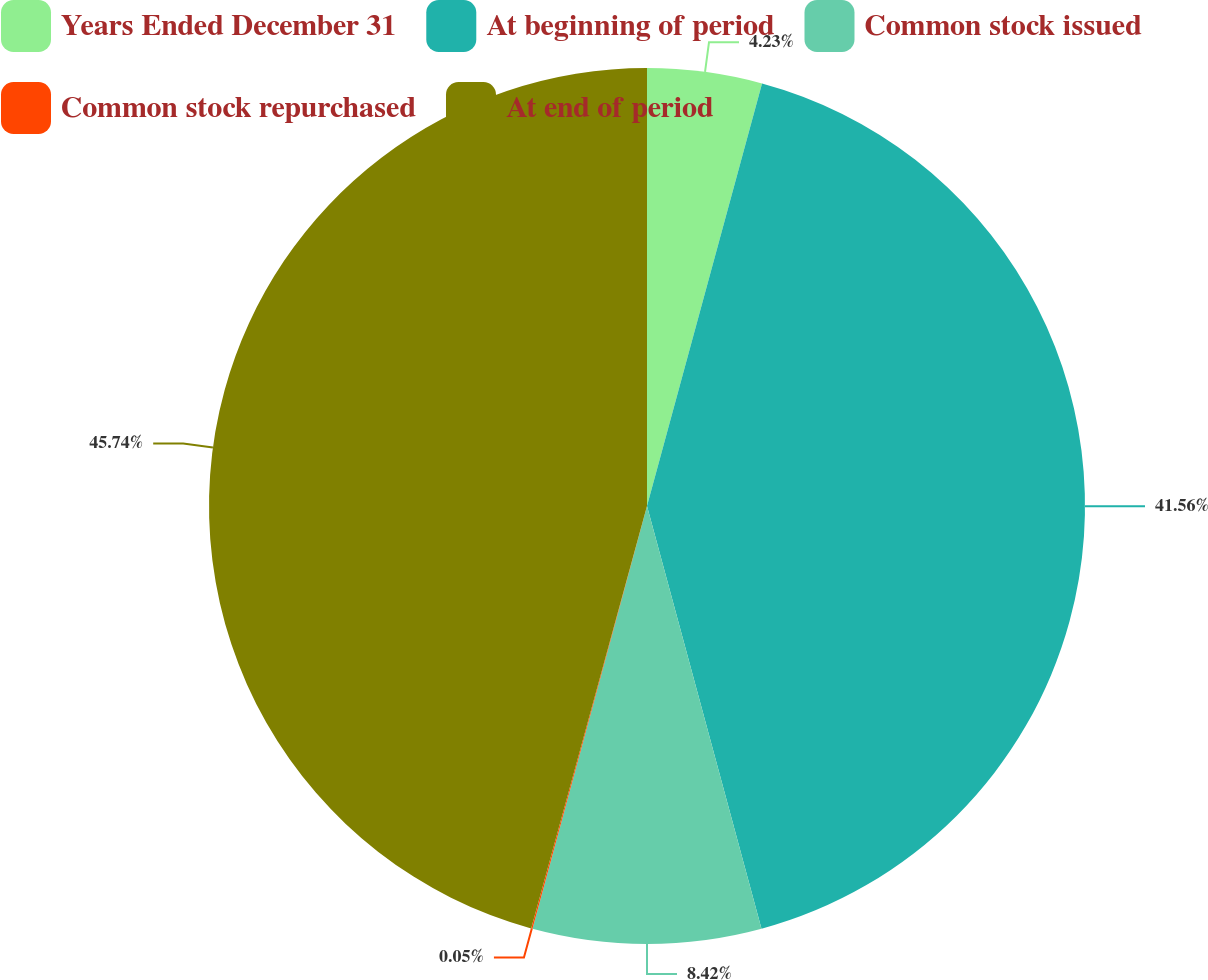<chart> <loc_0><loc_0><loc_500><loc_500><pie_chart><fcel>Years Ended December 31<fcel>At beginning of period<fcel>Common stock issued<fcel>Common stock repurchased<fcel>At end of period<nl><fcel>4.23%<fcel>41.56%<fcel>8.42%<fcel>0.05%<fcel>45.74%<nl></chart> 